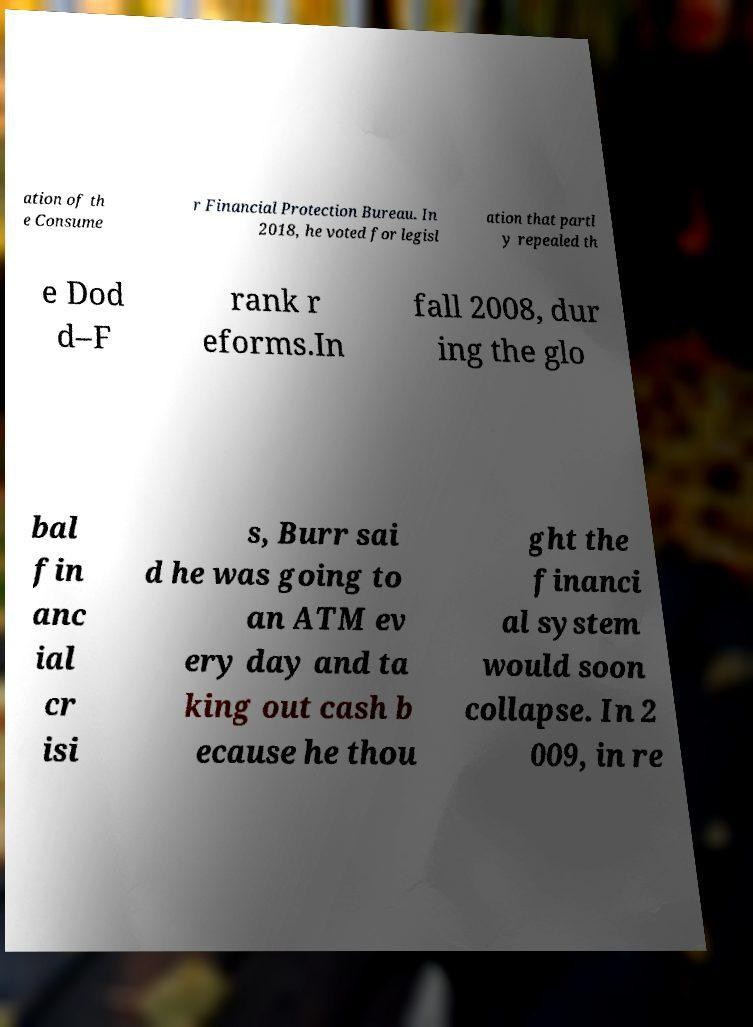Could you assist in decoding the text presented in this image and type it out clearly? ation of th e Consume r Financial Protection Bureau. In 2018, he voted for legisl ation that partl y repealed th e Dod d–F rank r eforms.In fall 2008, dur ing the glo bal fin anc ial cr isi s, Burr sai d he was going to an ATM ev ery day and ta king out cash b ecause he thou ght the financi al system would soon collapse. In 2 009, in re 